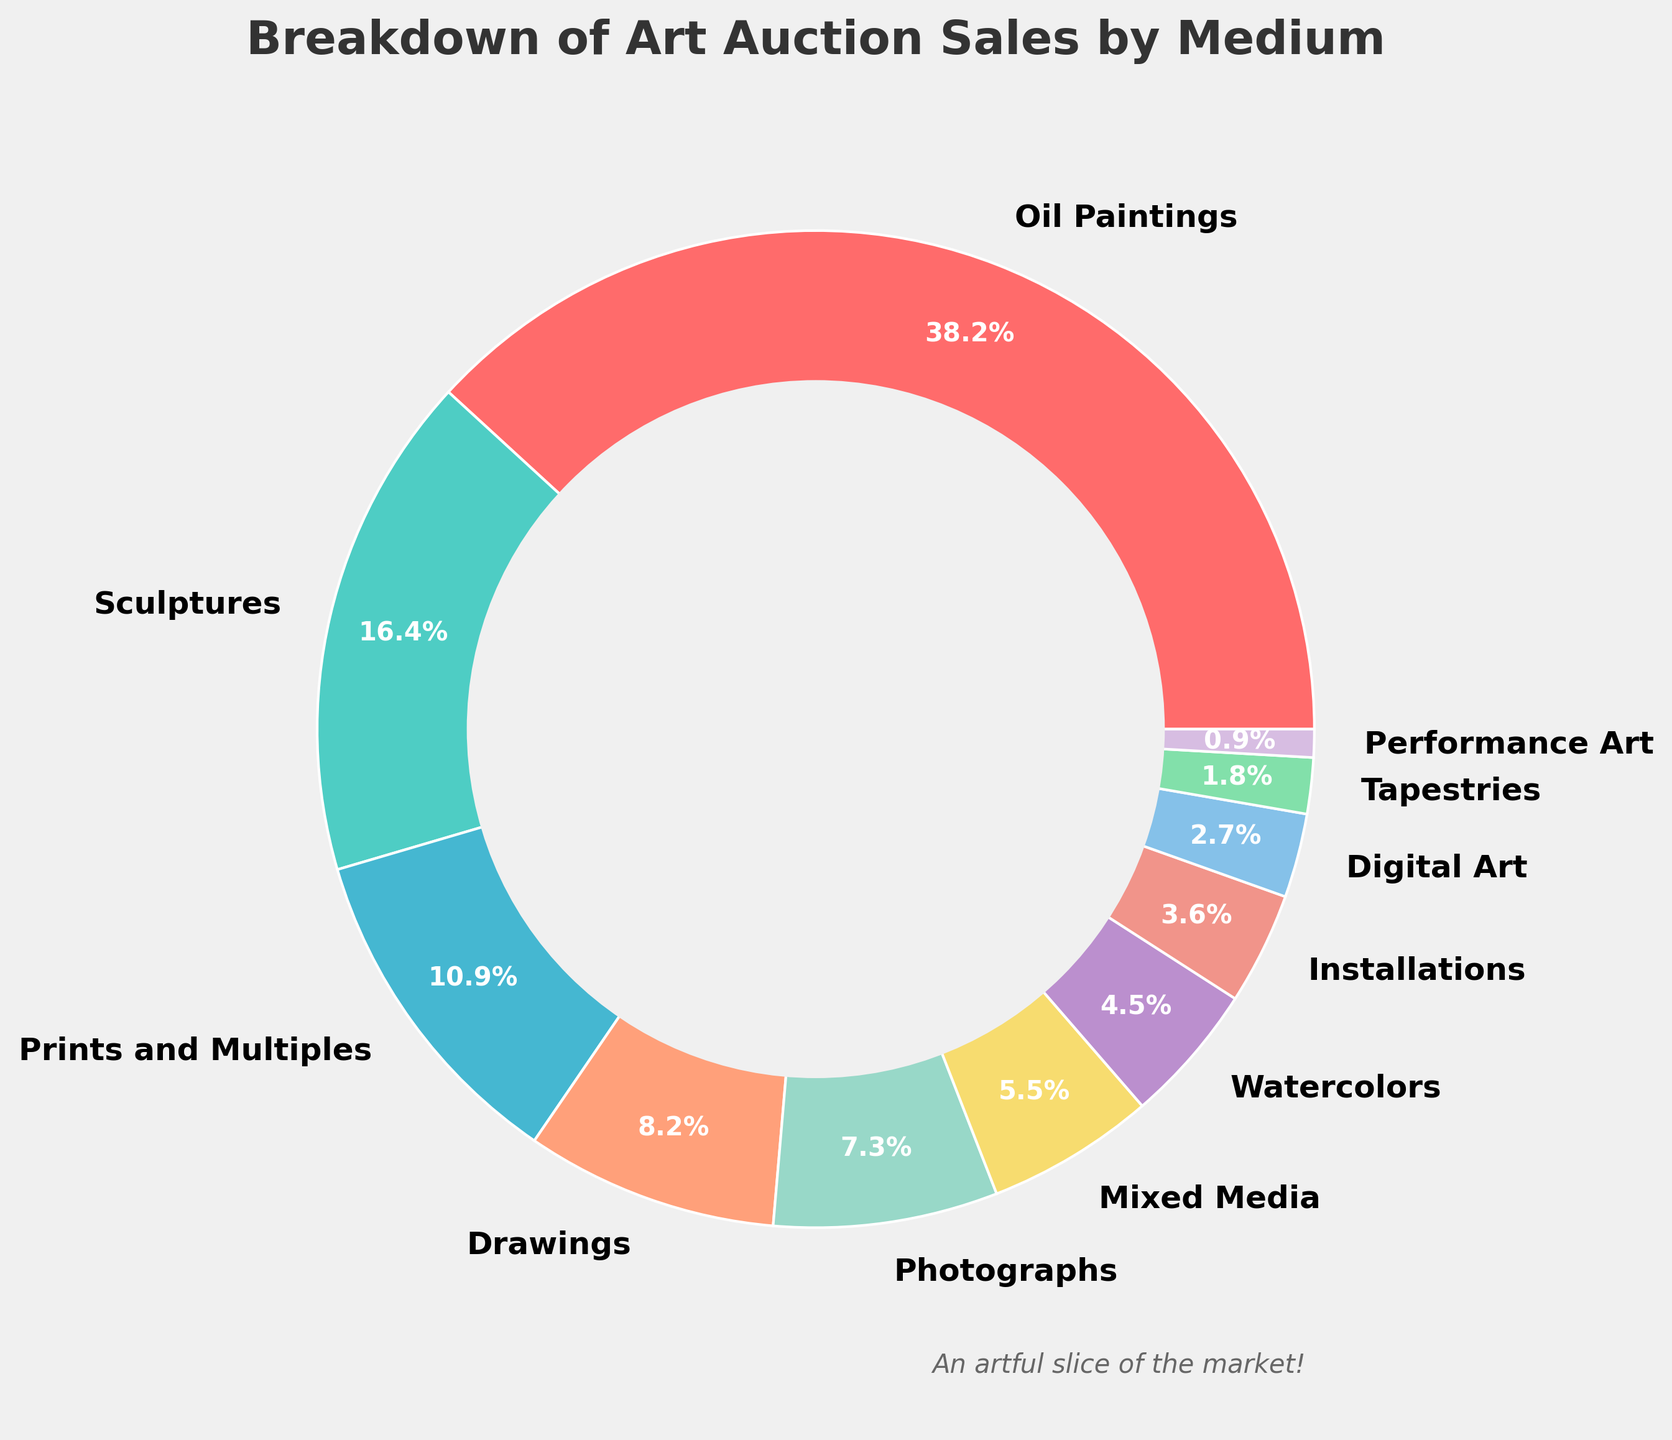What is the most represented medium in art auction sales? The figure shows the percentages of different mediums in a pie chart. The largest wedge, in this case, corresponds to oil paintings.
Answer: Oil Paintings Which medium accounts for 12% of art auction sales? By referring to the pie chart, the segment labeled "Prints and Multiples" corresponds to 12% of the sales.
Answer: Prints and Multiples How does the total percentage of Oil Paintings and Sculptures compare to the total percentage of Digital Art and Installations? Oil Paintings are 42%, and Sculptures are 18%, making their sum: 42 + 18 = 60%. Digital Art is 3%, and Installations are 4%, making their sum: 3 + 4 = 7%. Therefore, 60% is greater than 7%.
Answer: 60% > 7% What is the combined share of traditional drawing media, including Drawings and Watercolors? Drawings constitute 9%, and Watercolors constitute 5%. Their combined share is 9 + 5 = 14%.
Answer: 14% Is the percentage of Photographs higher or lower than that of Mixed Media? The pie chart shows that Photographs account for 8%, whereas Mixed Media accounts for 6%. Thus, Photographs have a higher percentage than Mixed Media.
Answer: Higher What is the least represented medium in the art auction sales? The smallest wedge on the pie chart represents "Performance Art," which accounts for 1% of the sales.
Answer: Performance Art How does the sum of the least three mediums compare to the sum of the top three mediums? The least three mediums are Performance Art (1%), Tapestries (2%), and Digital Art (3%). Their sum is 1 + 2 + 3 = 6%. The top three mediums are Oil Paintings (42%), Sculptures (18%), and Prints and Multiples (12%). Their sum is 42 + 18 + 12 = 72%. Thus, 6% is much less than 72%.
Answer: 6% < 72% What is the proportion of the pie chart devoted to non-traditional media (Mixed Media, Digital Art, Performance Art, Installations)? Mixed Media (6%), Digital Art (3%), Performance Art (1%), Installations (4%). Adding these gives 6 + 3 + 1 + 4 = 14%.
Answer: 14% Which medium has a higher percentage, Watercolors or Installations, and by how much? The pie chart shows Watercolors at 5% and Installations at 4%. The difference is 5 - 4 = 1%. Watercolors have a higher percentage by 1%.
Answer: Watercolors by 1% How much more prevalent are Oil Paintings compared to Drawings? Oil Paintings make up 42% of the sales, while Drawings make up 9%. The difference is 42 - 9 = 33%. Oil Paintings are 33% more prevalent than Drawings.
Answer: 33% 